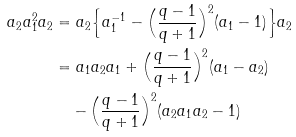<formula> <loc_0><loc_0><loc_500><loc_500>a _ { 2 } a _ { 1 } ^ { 2 } a _ { 2 } & = a _ { 2 } \Big { \{ } a _ { 1 } ^ { - 1 } - \Big { ( } \frac { q - 1 } { q + 1 } \Big { ) } ^ { 2 } ( a _ { 1 } - 1 ) \Big { \} } a _ { 2 } \\ & = a _ { 1 } a _ { 2 } a _ { 1 } + \Big { ( } \frac { q - 1 } { q + 1 } \Big { ) } ^ { 2 } ( a _ { 1 } - a _ { 2 } ) \\ & \quad - \Big { ( } \frac { q - 1 } { q + 1 } \Big { ) } ^ { 2 } ( a _ { 2 } a _ { 1 } a _ { 2 } - 1 )</formula> 